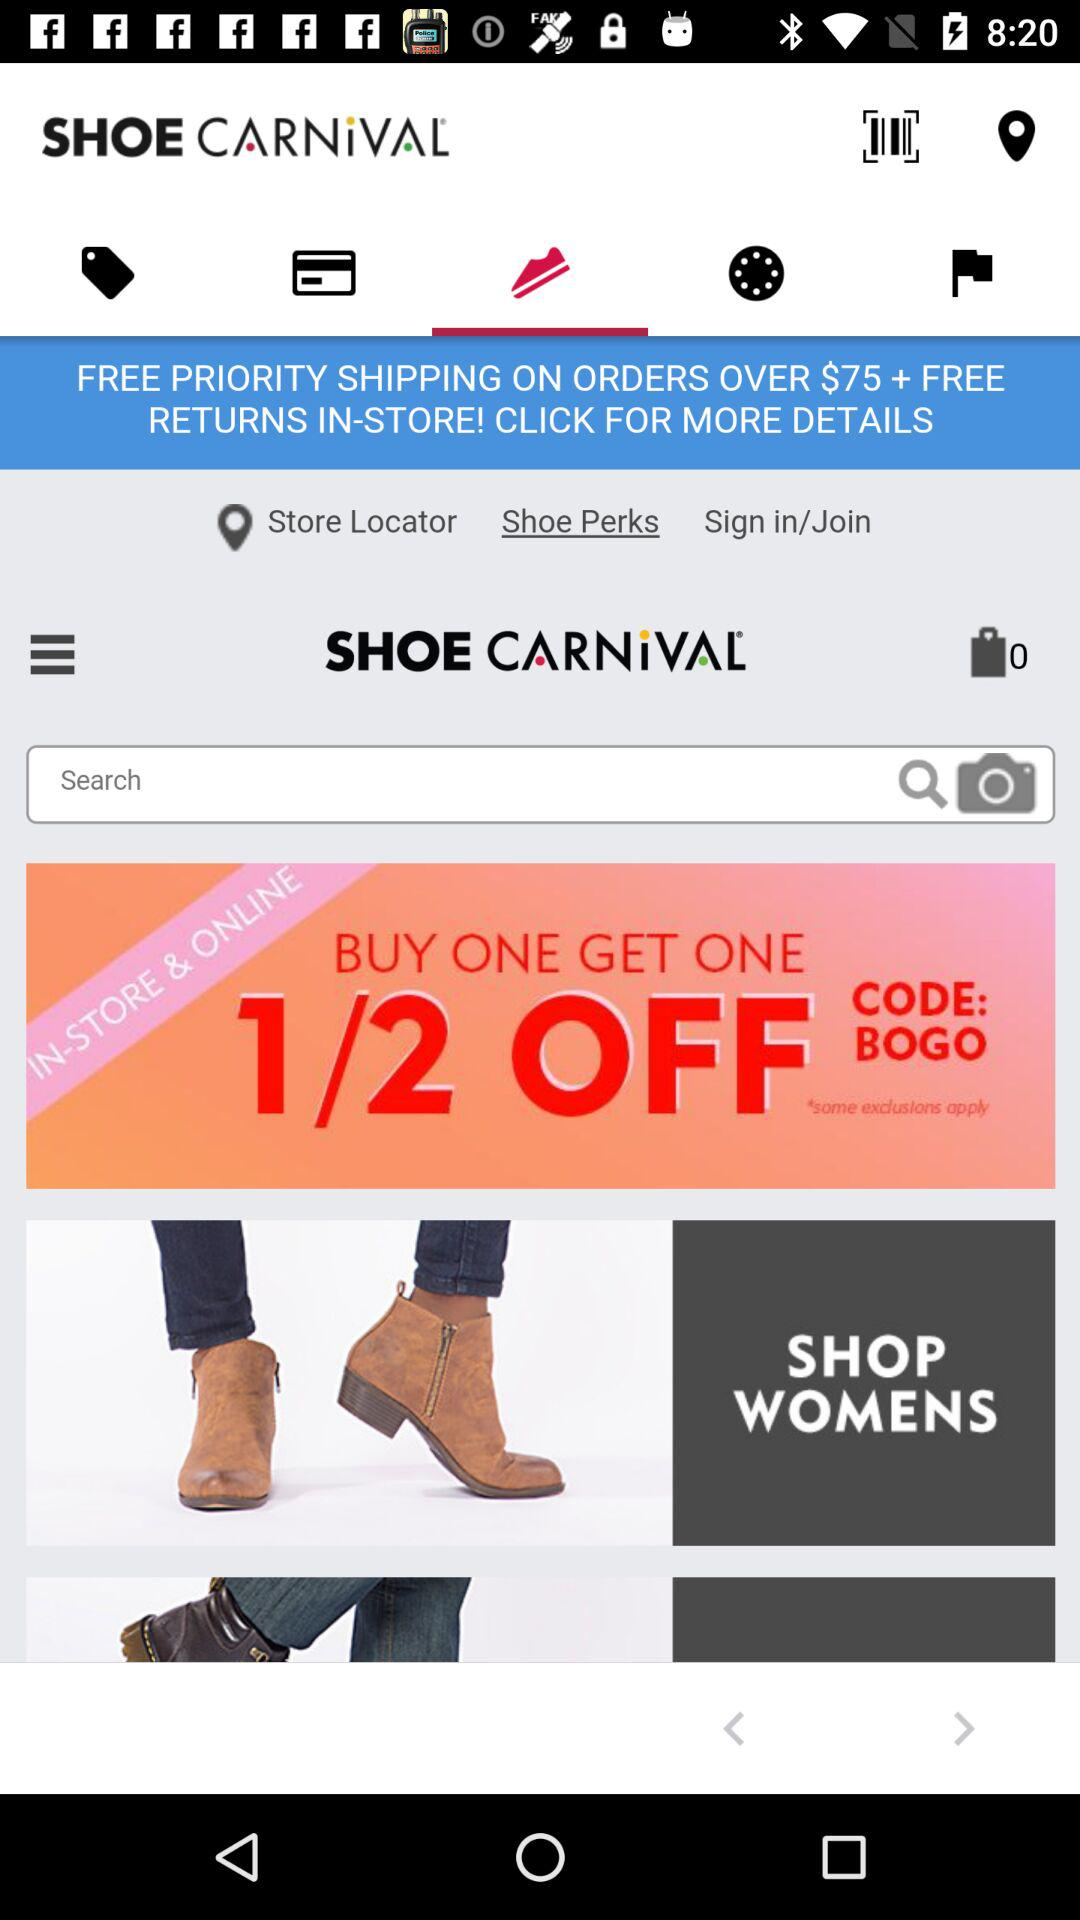What's the offer? The offers are "FREE PRIORITY SHIPPING ON ORDERS OVER $75 + FREE RETURNS IN-STORE!" and "BUY ONE GET ONE". 